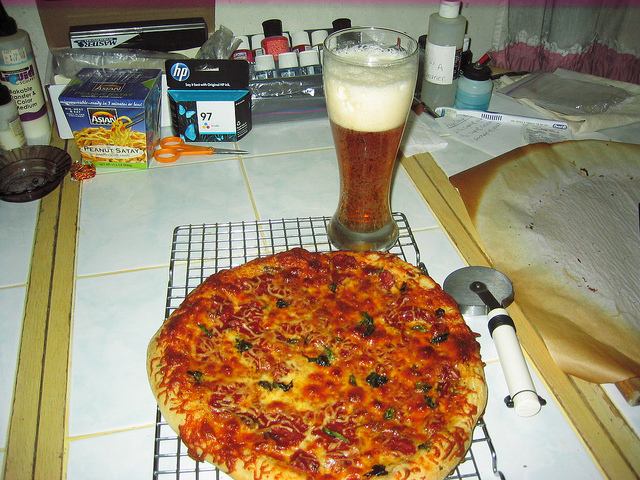Read and extract the text from this image. HP 97 ASIAN PEANUT MASTER 